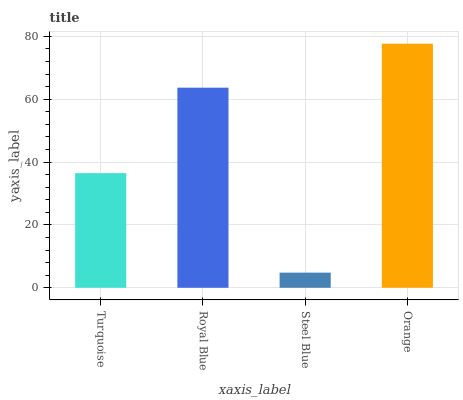Is Royal Blue the minimum?
Answer yes or no. No. Is Royal Blue the maximum?
Answer yes or no. No. Is Royal Blue greater than Turquoise?
Answer yes or no. Yes. Is Turquoise less than Royal Blue?
Answer yes or no. Yes. Is Turquoise greater than Royal Blue?
Answer yes or no. No. Is Royal Blue less than Turquoise?
Answer yes or no. No. Is Royal Blue the high median?
Answer yes or no. Yes. Is Turquoise the low median?
Answer yes or no. Yes. Is Orange the high median?
Answer yes or no. No. Is Royal Blue the low median?
Answer yes or no. No. 